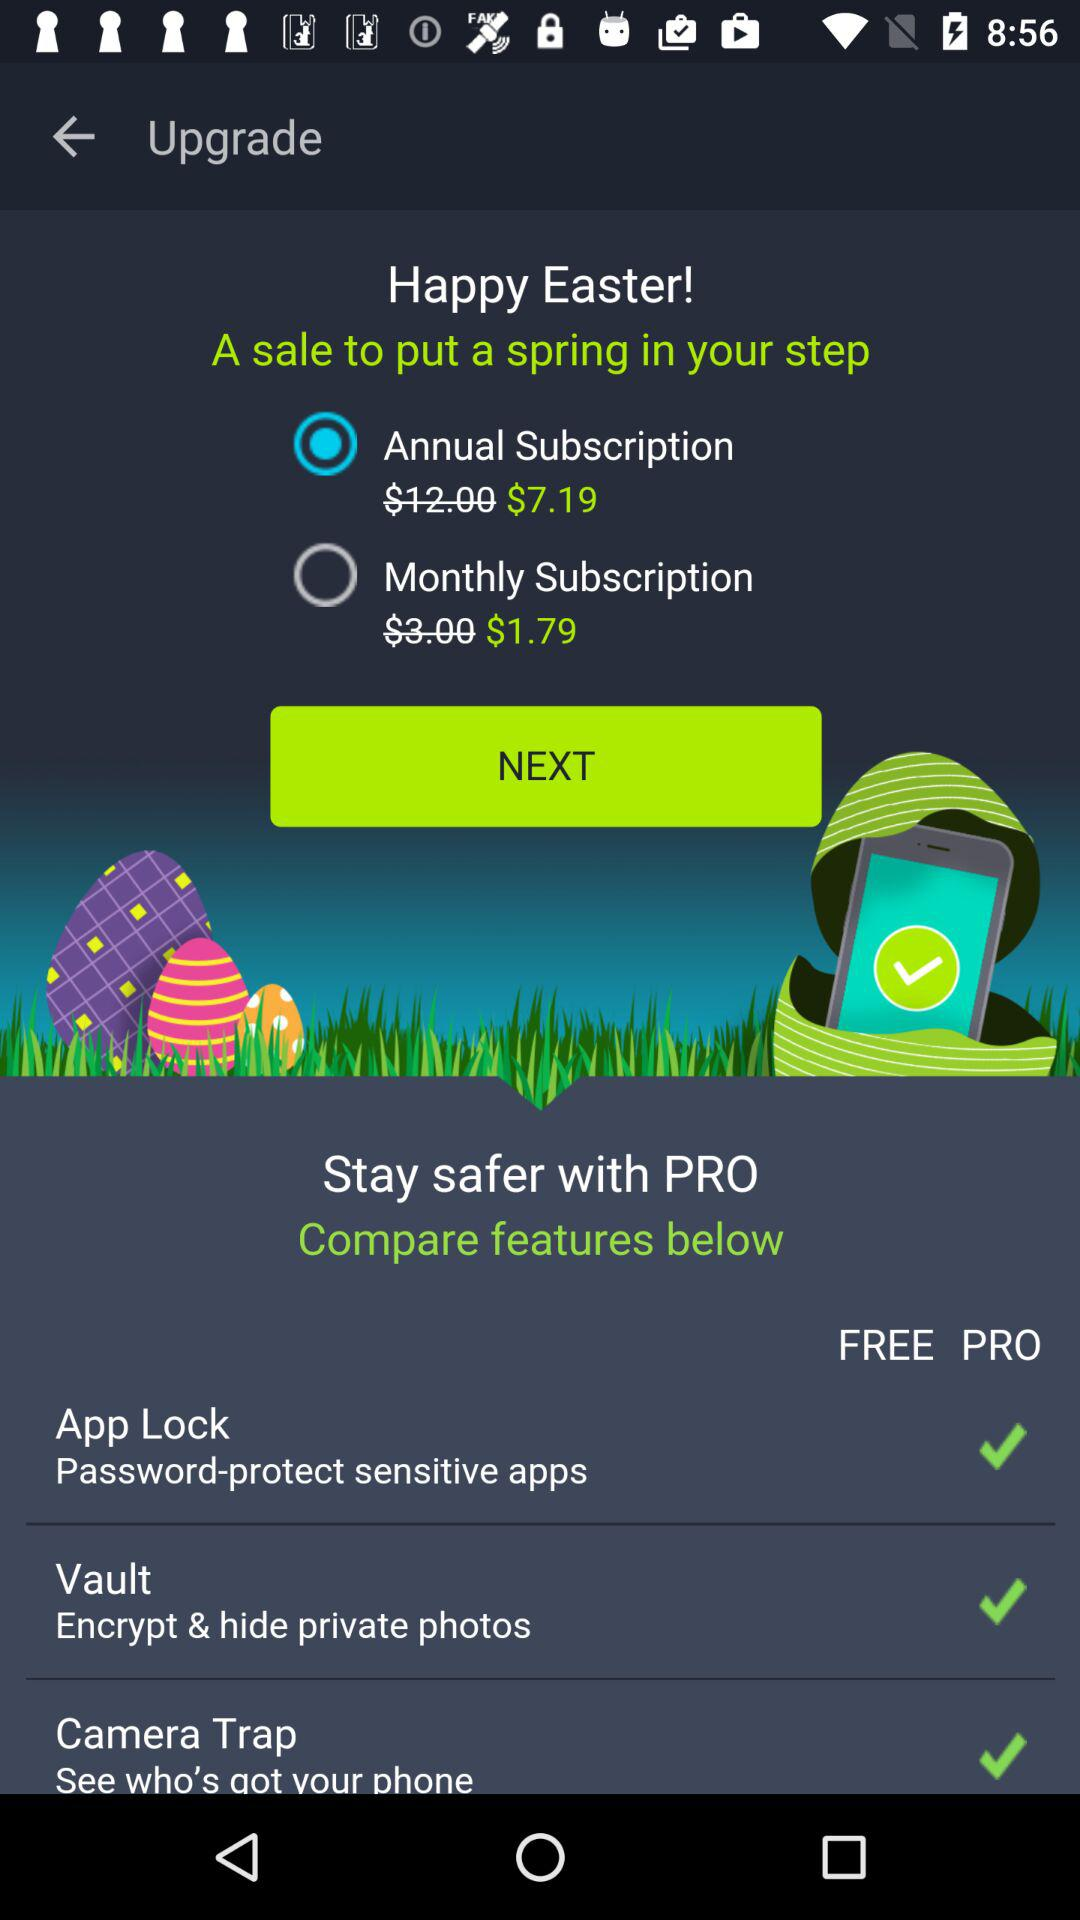Where can we keep our personal photos hidden? You can keep your personal photos hidden in the vault. 